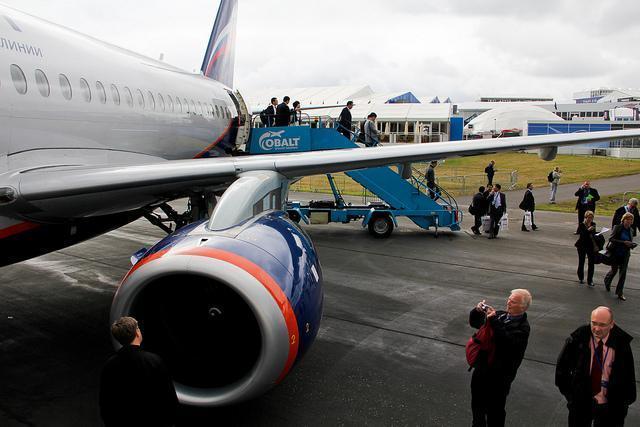How many people are there?
Give a very brief answer. 3. How many rolls of toilet paper are there?
Give a very brief answer. 0. 